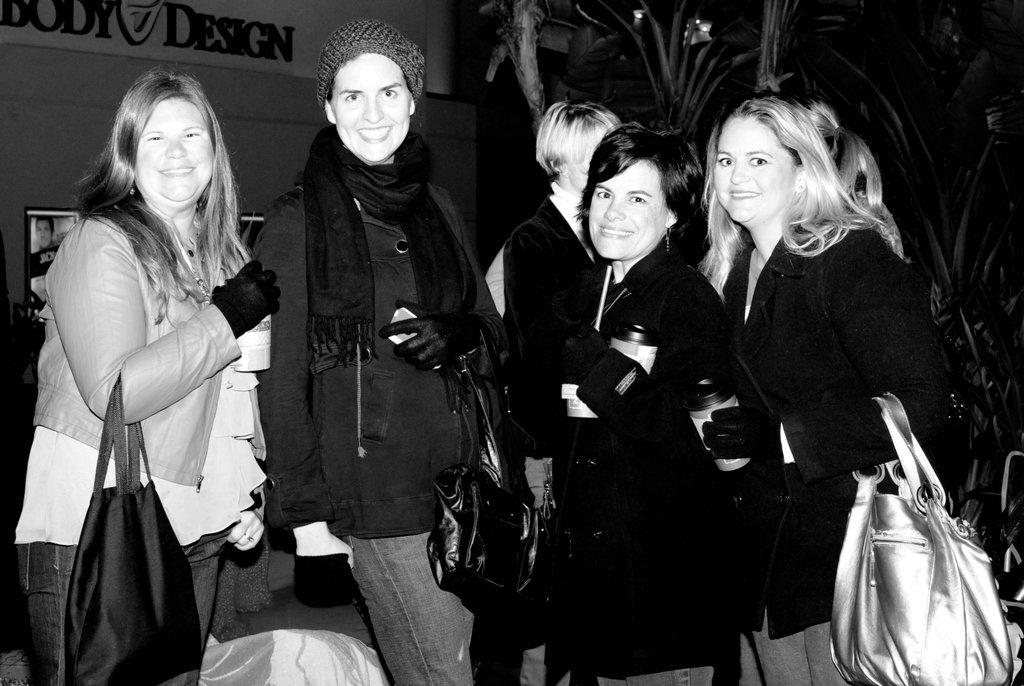What is the main subject of the image? The main subject of the image is a group of women. What are the women doing in the image? The women are posing to the camera. What type of offer is being made by the women in the image? There is no offer being made by the women in the image; they are simply posing to the camera. Is there a river visible in the image? No, there is no river present in the image. 